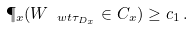<formula> <loc_0><loc_0><loc_500><loc_500>\P _ { x } ( W _ { \ w t \tau _ { D _ { x } } } \in C _ { x } ) \geq c _ { 1 } \, .</formula> 